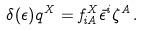Convert formula to latex. <formula><loc_0><loc_0><loc_500><loc_500>\delta ( \epsilon ) q ^ { X } = f _ { i A } ^ { X } \bar { \epsilon } ^ { i } \zeta ^ { A } \, .</formula> 